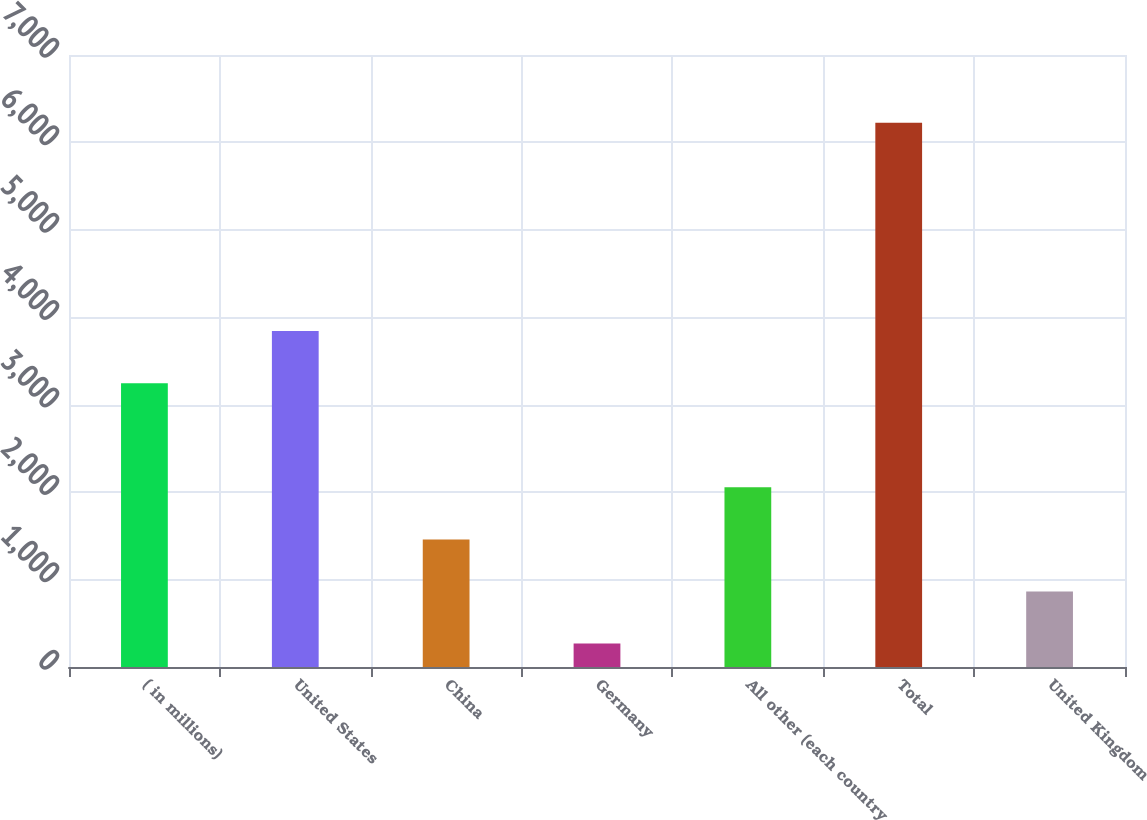<chart> <loc_0><loc_0><loc_500><loc_500><bar_chart><fcel>( in millions)<fcel>United States<fcel>China<fcel>Germany<fcel>All other (each country<fcel>Total<fcel>United Kingdom<nl><fcel>3246.2<fcel>3841.82<fcel>1459.34<fcel>268.1<fcel>2054.96<fcel>6224.3<fcel>863.72<nl></chart> 